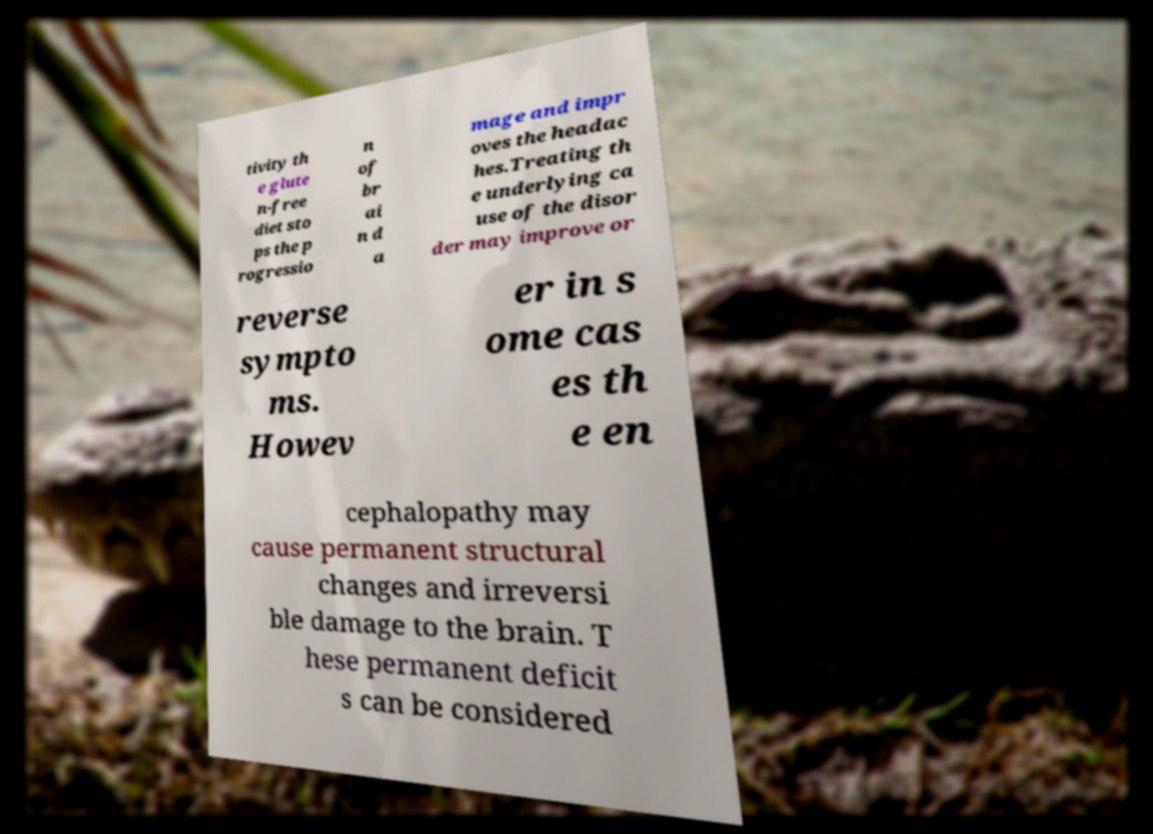Please read and relay the text visible in this image. What does it say? tivity th e glute n-free diet sto ps the p rogressio n of br ai n d a mage and impr oves the headac hes.Treating th e underlying ca use of the disor der may improve or reverse sympto ms. Howev er in s ome cas es th e en cephalopathy may cause permanent structural changes and irreversi ble damage to the brain. T hese permanent deficit s can be considered 